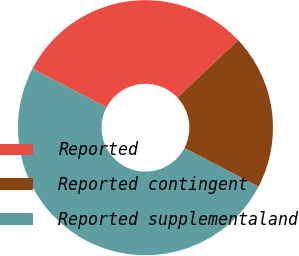Convert chart. <chart><loc_0><loc_0><loc_500><loc_500><pie_chart><fcel>Reported<fcel>Reported contingent<fcel>Reported supplementaland<nl><fcel>30.3%<fcel>19.7%<fcel>50.0%<nl></chart> 